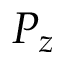Convert formula to latex. <formula><loc_0><loc_0><loc_500><loc_500>P _ { z }</formula> 